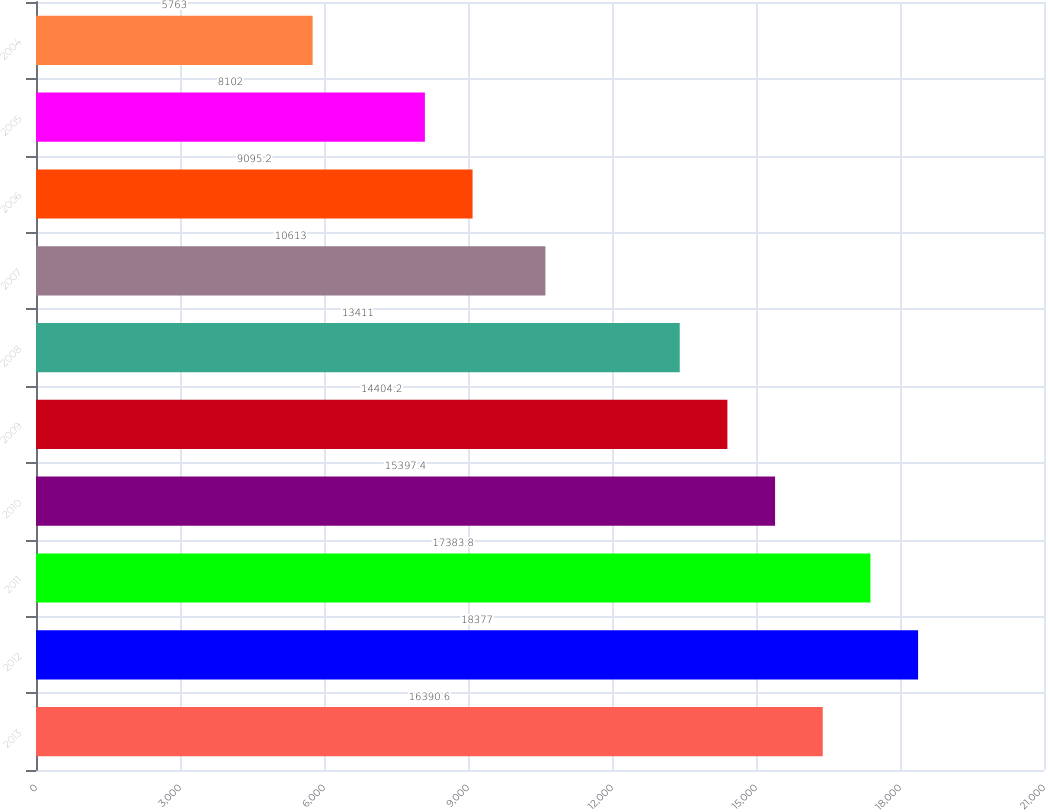<chart> <loc_0><loc_0><loc_500><loc_500><bar_chart><fcel>2013<fcel>2012<fcel>2011<fcel>2010<fcel>2009<fcel>2008<fcel>2007<fcel>2006<fcel>2005<fcel>2004<nl><fcel>16390.6<fcel>18377<fcel>17383.8<fcel>15397.4<fcel>14404.2<fcel>13411<fcel>10613<fcel>9095.2<fcel>8102<fcel>5763<nl></chart> 